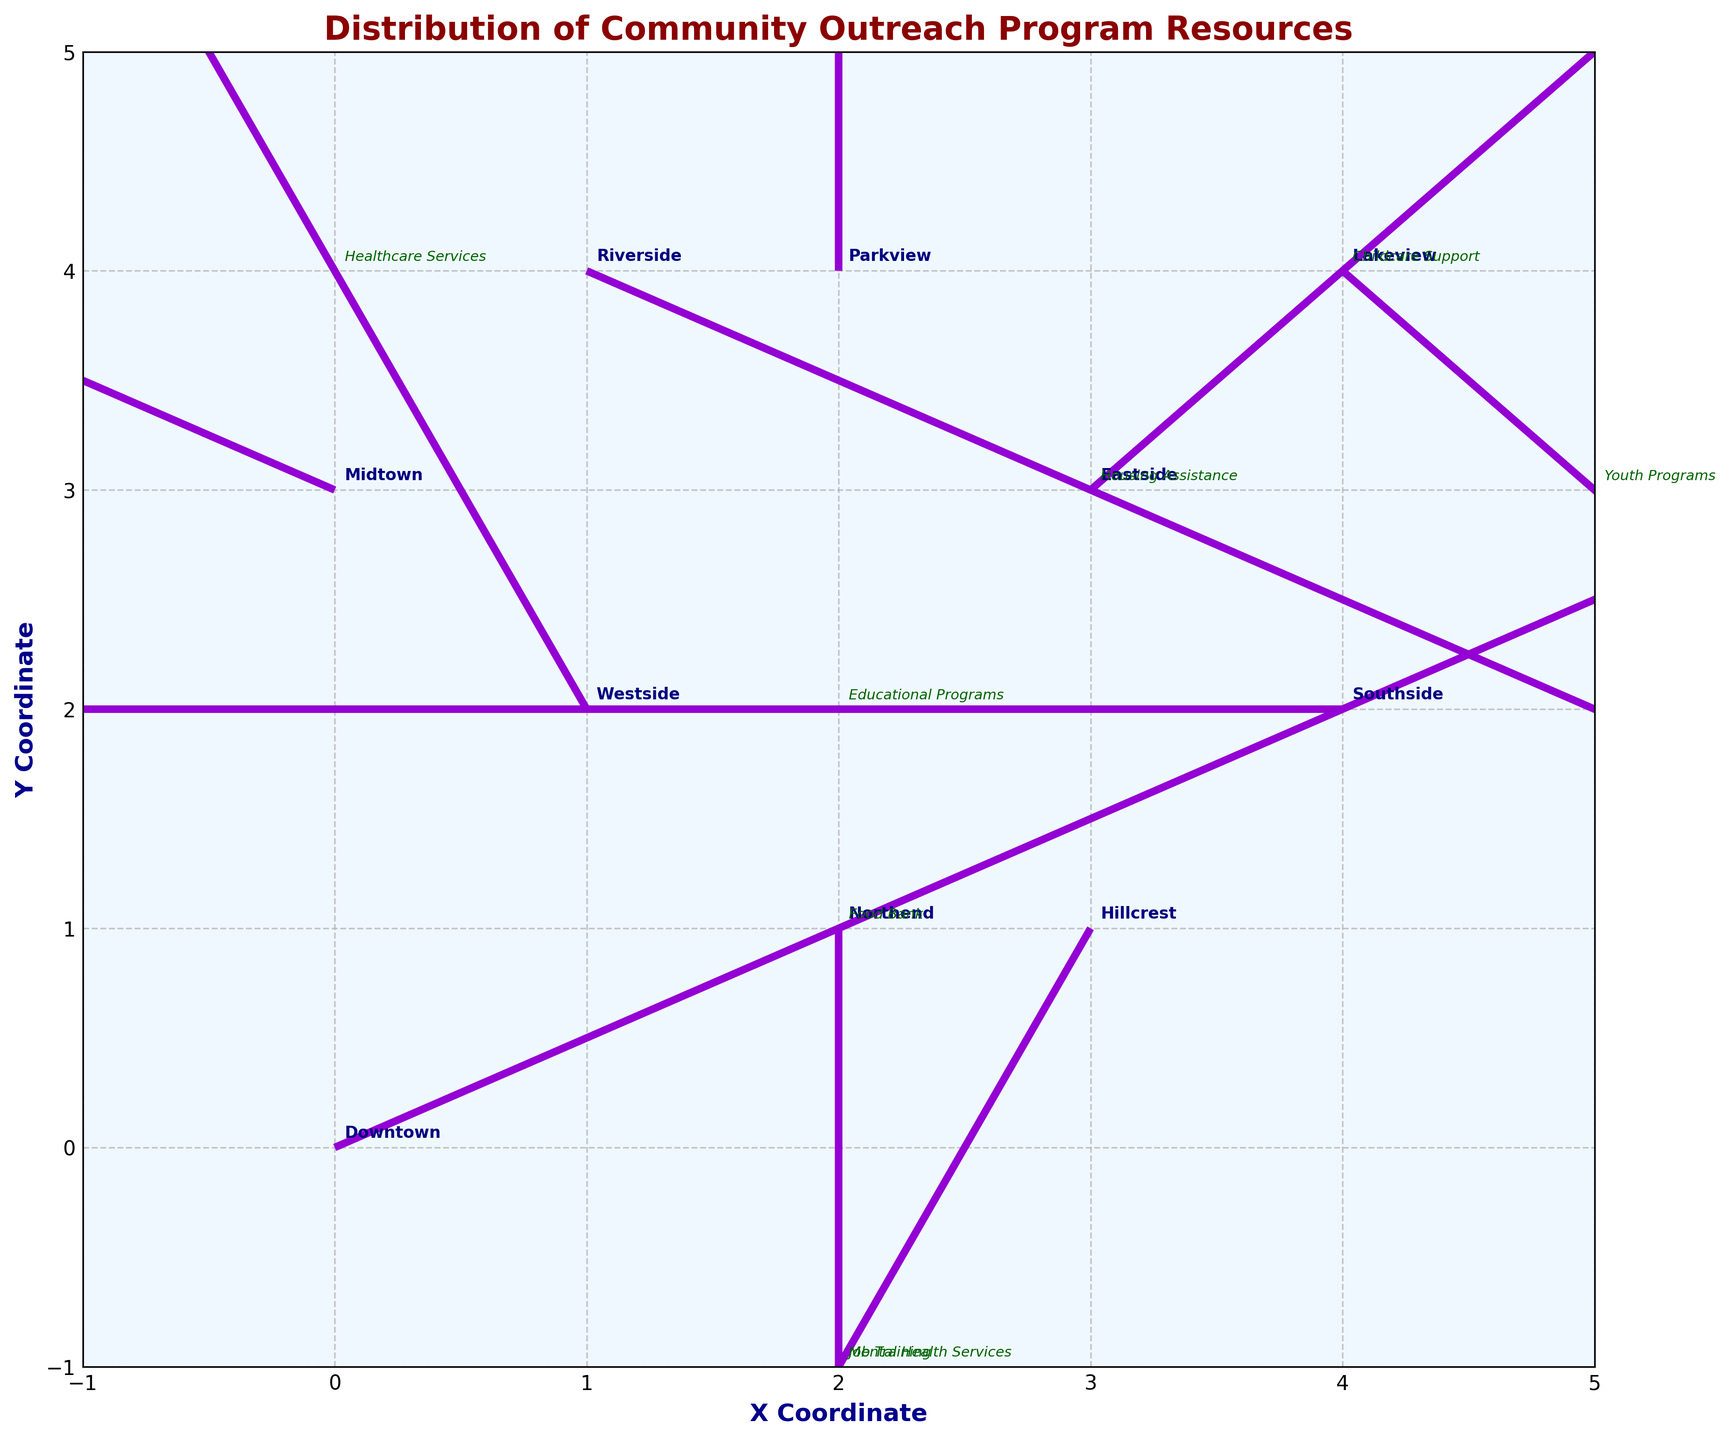What is the title of the quiver plot? The title of the quiver plot is located at the top center of the figure and is typically bolded and larger in font size compared to other text elements.
Answer: Distribution of Community Outreach Program Resources What are the coordinates of the arrow that represents "Healthcare Services"? Locate the arrow labeled "Westside" representing "Healthcare Services". The arrow starts at (1, 2).
Answer: (1, 2) Which neighborhood shows a resource flow with the largest horizontal component in the positive direction? To identify this, look for the arrow with the largest positive x-component (u). The arrow in "Riverside" with u=2 is the largest in the positive direction.
Answer: Riverside Which two neighborhoods have their resources moving in the opposite vertical direction? Compare the arrows' vertical components v. "Westside" (v=2) and "Northend" (v=-2) are moving in opposite vertical directions.
Answer: Westside and Northend What is the x-coordinate of the neighborhood "Lakeview"? Find the label "Lakeview" and note the x-coordinate of the starting point of its arrow. The coordinate is 4.
Answer: 4 How many neighborhoods have their resource flow touching or crossing the x-axis? Examine the arrows and see whether their end points (x+u) touch or cross y=0. Only "Northend" and "Hillcrest" meet this criteria.
Answer: 2 Which neighborhood has the arrows whose direction remains purely vertical? Identify an arrow where the horizontal component (u) is zero. "Northend" has an arrow with u=0.
Answer: Northend Compare "Southside" and "Parkview". Which has a larger vertical flow component? "Southside" has v=0. "Parkview" has v=2. Thus, "Parkview" has a larger vertical component.
Answer: Parkview What is the y-coordinate of the starting point for "Midtown"? Locate "Midtown" and note the y-coordinate of its starting point. The coordinate is 3.
Answer: 3 Which resource type flows the furthest distance in the negative direction horizontally? By examining the negative horizontal components (-u), "Educational Programs" in "Southside" has the largest negative horizontal component u=-2, thus covering the furthest distance in the negative direction.
Answer: Educational Programs 